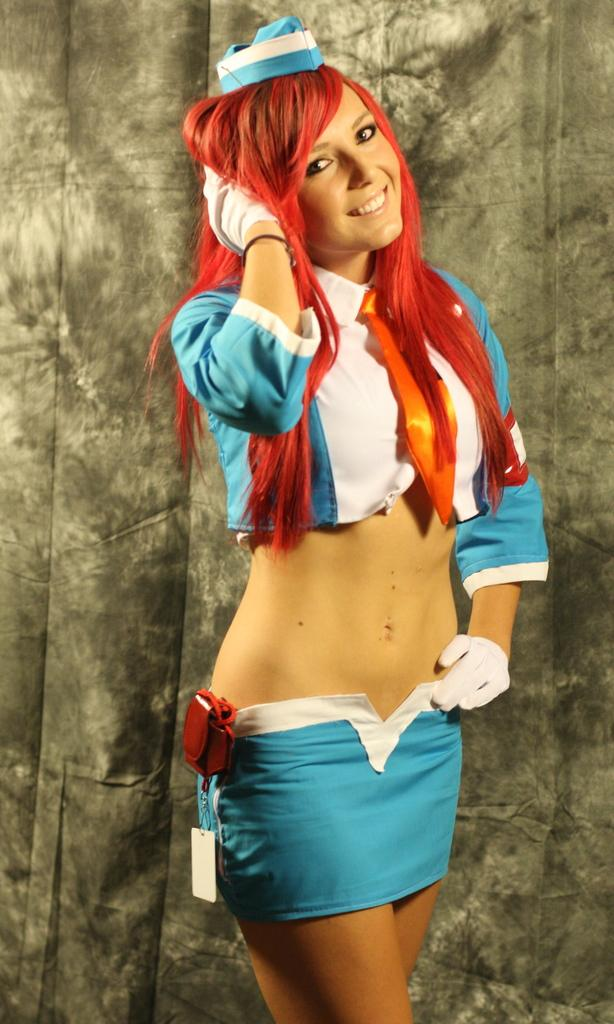Who is present in the image? There is a woman in the image. What is the woman wearing on her head? The woman is wearing a red hat. What is the woman's facial expression in the image? The woman is smiling. What can be seen in the background of the image? There is cloth visible in the background of the image. Can you tell me how many units of water are flowing in the stream behind the woman? There is no stream present in the image, so it is not possible to determine the number of units of water flowing in it. 